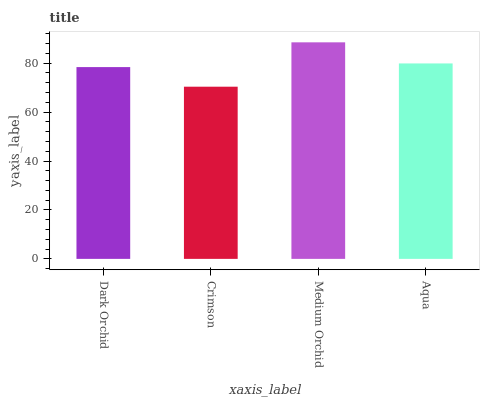Is Medium Orchid the minimum?
Answer yes or no. No. Is Crimson the maximum?
Answer yes or no. No. Is Medium Orchid greater than Crimson?
Answer yes or no. Yes. Is Crimson less than Medium Orchid?
Answer yes or no. Yes. Is Crimson greater than Medium Orchid?
Answer yes or no. No. Is Medium Orchid less than Crimson?
Answer yes or no. No. Is Aqua the high median?
Answer yes or no. Yes. Is Dark Orchid the low median?
Answer yes or no. Yes. Is Dark Orchid the high median?
Answer yes or no. No. Is Aqua the low median?
Answer yes or no. No. 